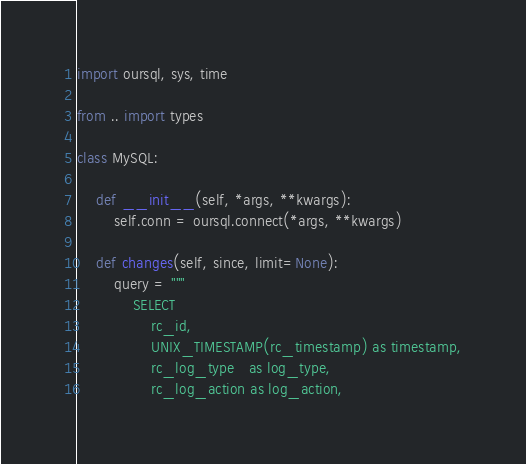<code> <loc_0><loc_0><loc_500><loc_500><_Python_>import oursql, sys, time

from .. import types

class MySQL:
	
	def __init__(self, *args, **kwargs):
		self.conn = oursql.connect(*args, **kwargs)
	
	def changes(self, since, limit=None):
		query = """
			SELECT
				rc_id,
				UNIX_TIMESTAMP(rc_timestamp) as timestamp,
				rc_log_type   as log_type,
				rc_log_action as log_action,</code> 